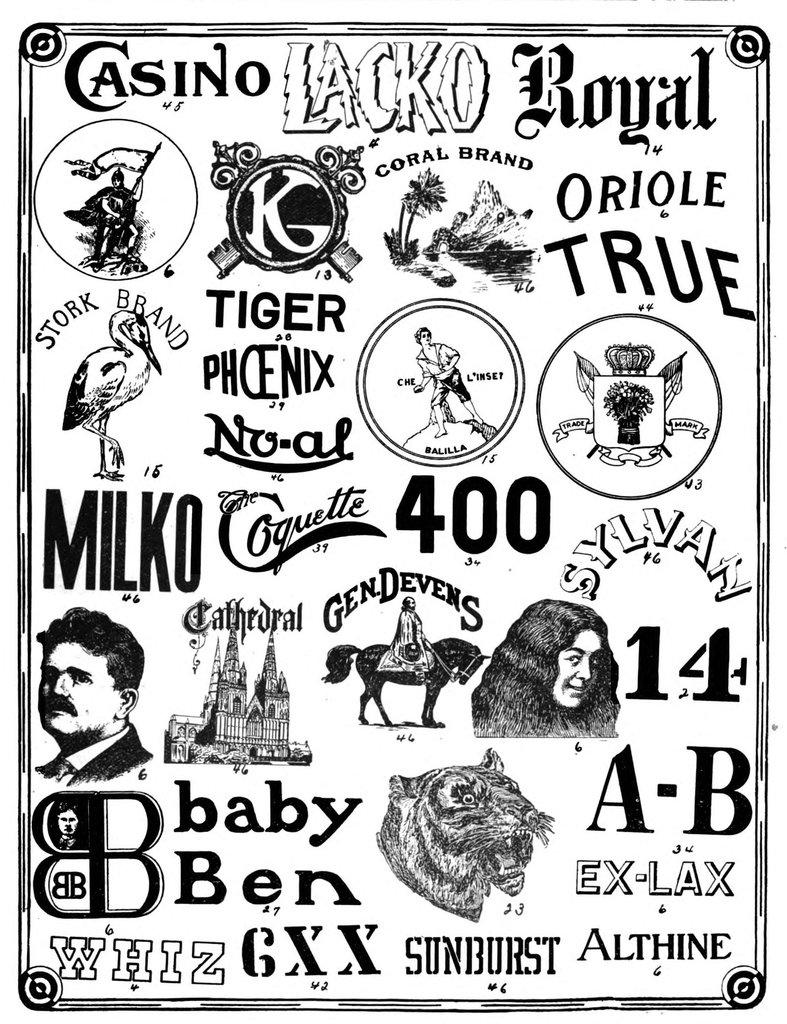What is present in the image that contains visual information? There is a poster in the image. What types of elements can be found on the poster? The poster contains logos and pictures. What type of quartz can be seen on the poster in the image? There is no quartz present on the poster in the image. What kind of wheel is depicted in the poster? There is no wheel depicted in the poster in the image. 